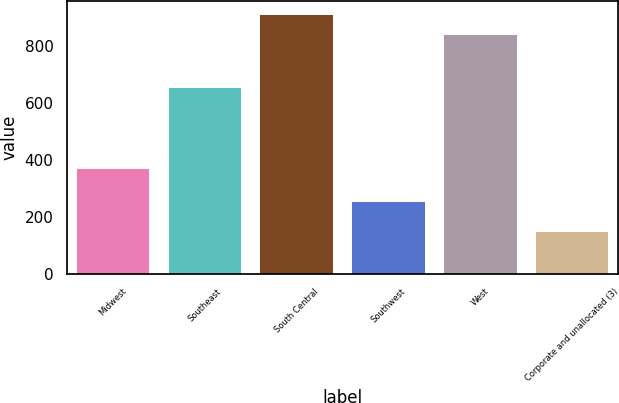Convert chart. <chart><loc_0><loc_0><loc_500><loc_500><bar_chart><fcel>Midwest<fcel>Southeast<fcel>South Central<fcel>Southwest<fcel>West<fcel>Corporate and unallocated (3)<nl><fcel>371.1<fcel>656.6<fcel>912.89<fcel>255.7<fcel>842.5<fcel>148.9<nl></chart> 